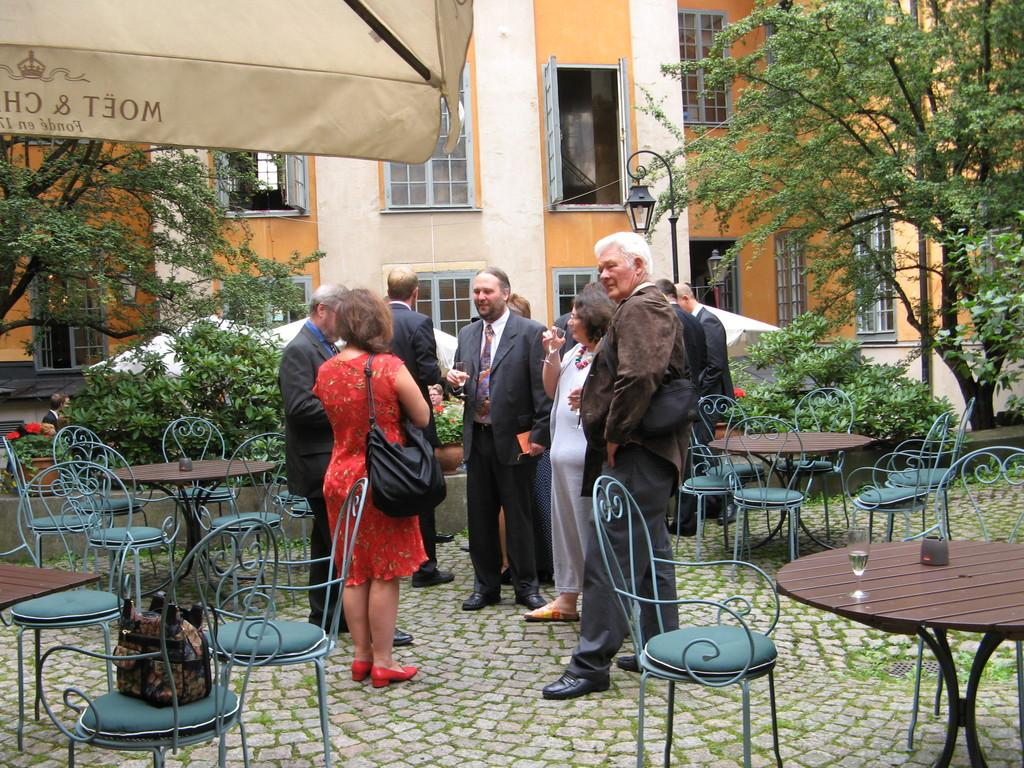What is happening in the image? There are people standing outside a building. What furniture is present in the image? There is a table surrounded by chairs. What objects are on the table? There are glasses on the table. What can be seen in the distance behind the people? There are trees and buildings in the background. Is there a cemetery visible in the background of the image? No, there is no cemetery present in the image. What type of authority figure can be seen in the image? There is no authority figure present in the image. 